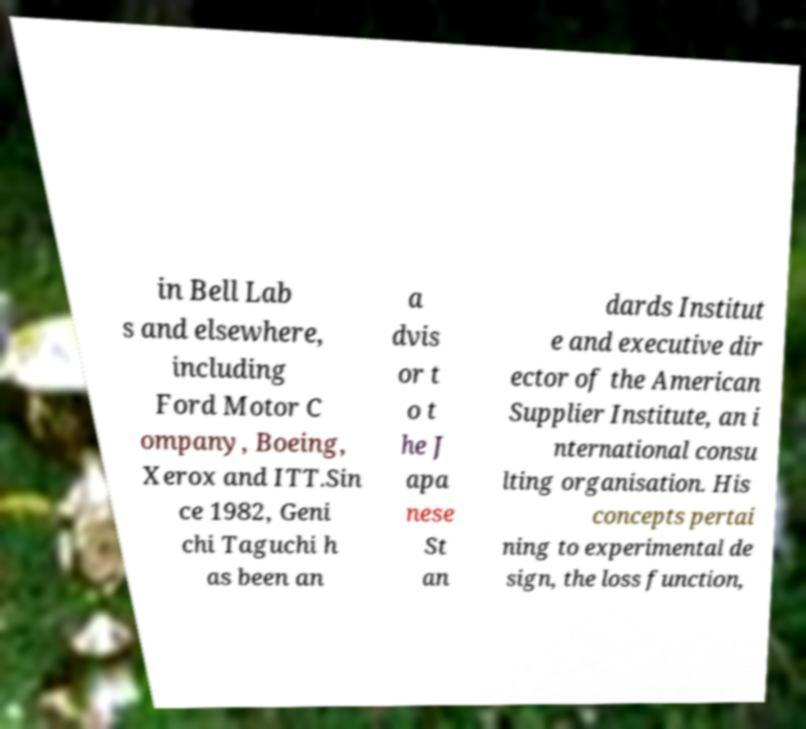Can you accurately transcribe the text from the provided image for me? in Bell Lab s and elsewhere, including Ford Motor C ompany, Boeing, Xerox and ITT.Sin ce 1982, Geni chi Taguchi h as been an a dvis or t o t he J apa nese St an dards Institut e and executive dir ector of the American Supplier Institute, an i nternational consu lting organisation. His concepts pertai ning to experimental de sign, the loss function, 